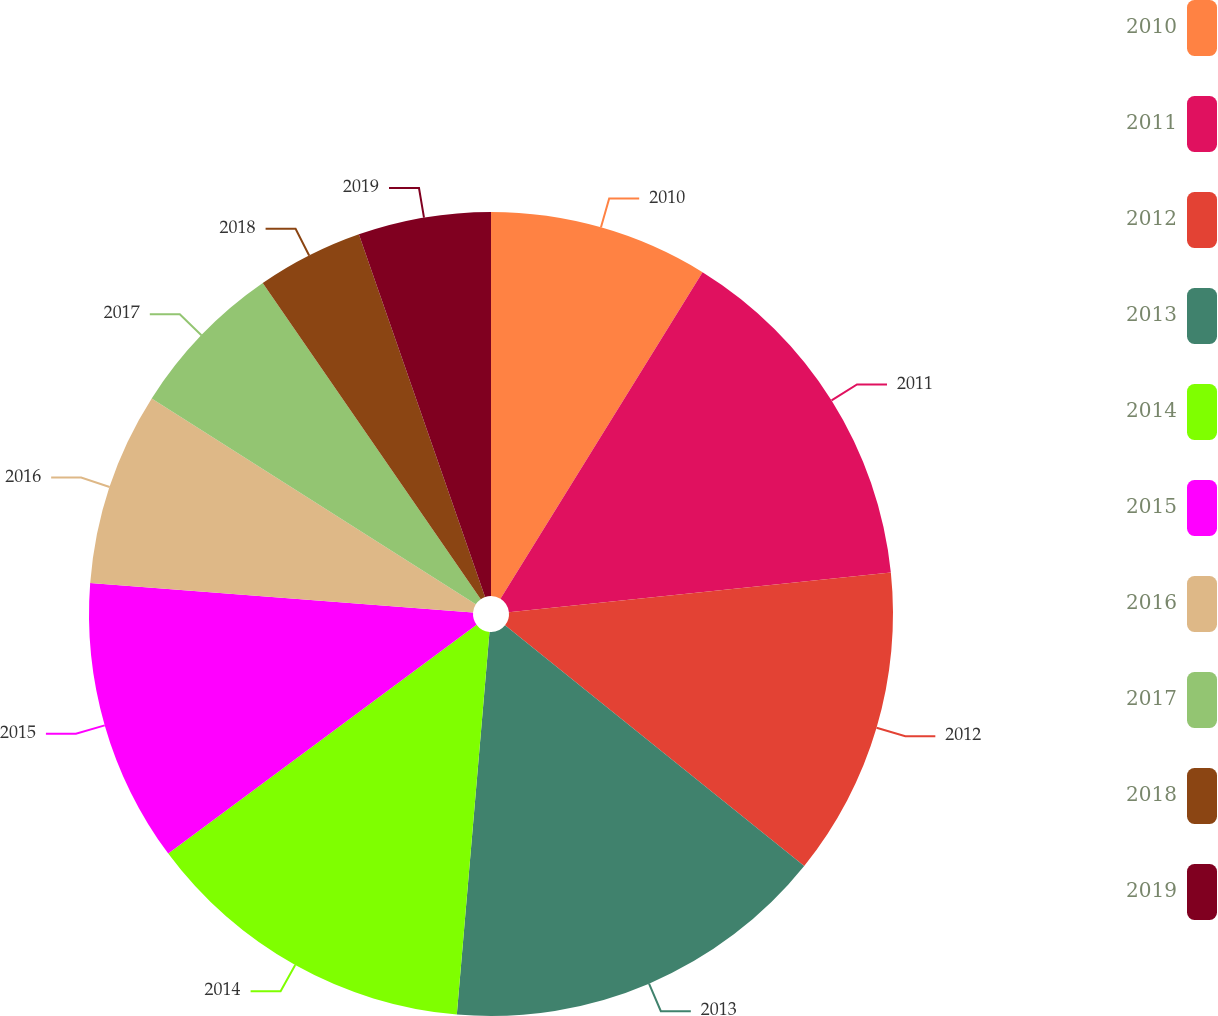<chart> <loc_0><loc_0><loc_500><loc_500><pie_chart><fcel>2010<fcel>2011<fcel>2012<fcel>2013<fcel>2014<fcel>2015<fcel>2016<fcel>2017<fcel>2018<fcel>2019<nl><fcel>8.82%<fcel>14.53%<fcel>12.43%<fcel>15.57%<fcel>13.48%<fcel>11.39%<fcel>7.78%<fcel>6.38%<fcel>4.28%<fcel>5.33%<nl></chart> 